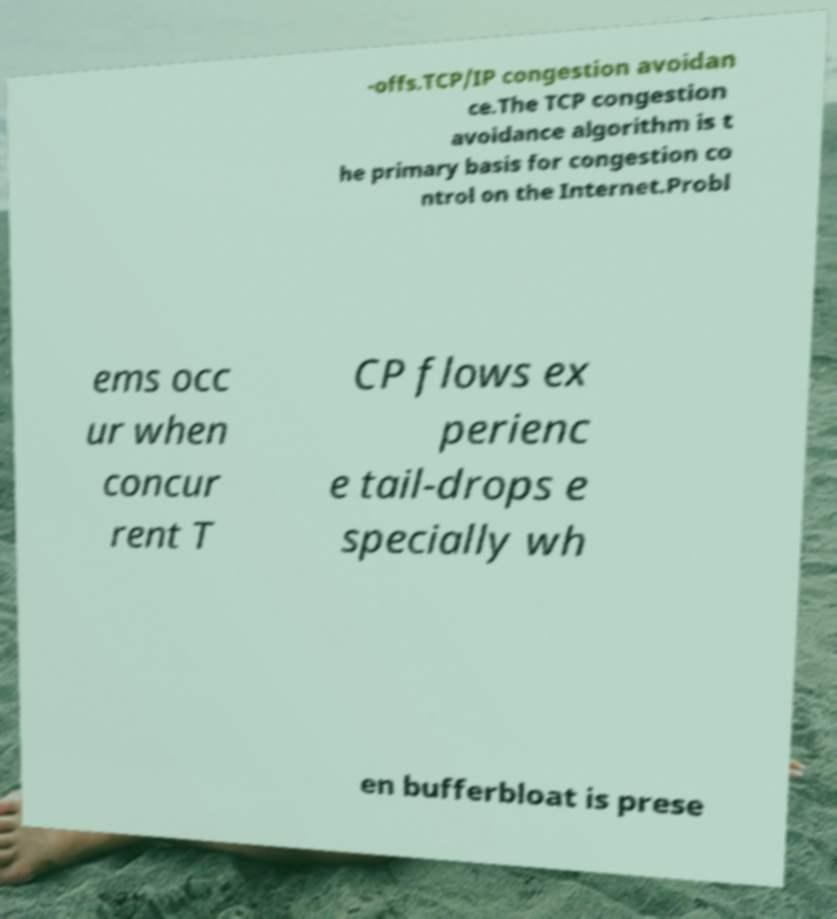For documentation purposes, I need the text within this image transcribed. Could you provide that? -offs.TCP/IP congestion avoidan ce.The TCP congestion avoidance algorithm is t he primary basis for congestion co ntrol on the Internet.Probl ems occ ur when concur rent T CP flows ex perienc e tail-drops e specially wh en bufferbloat is prese 